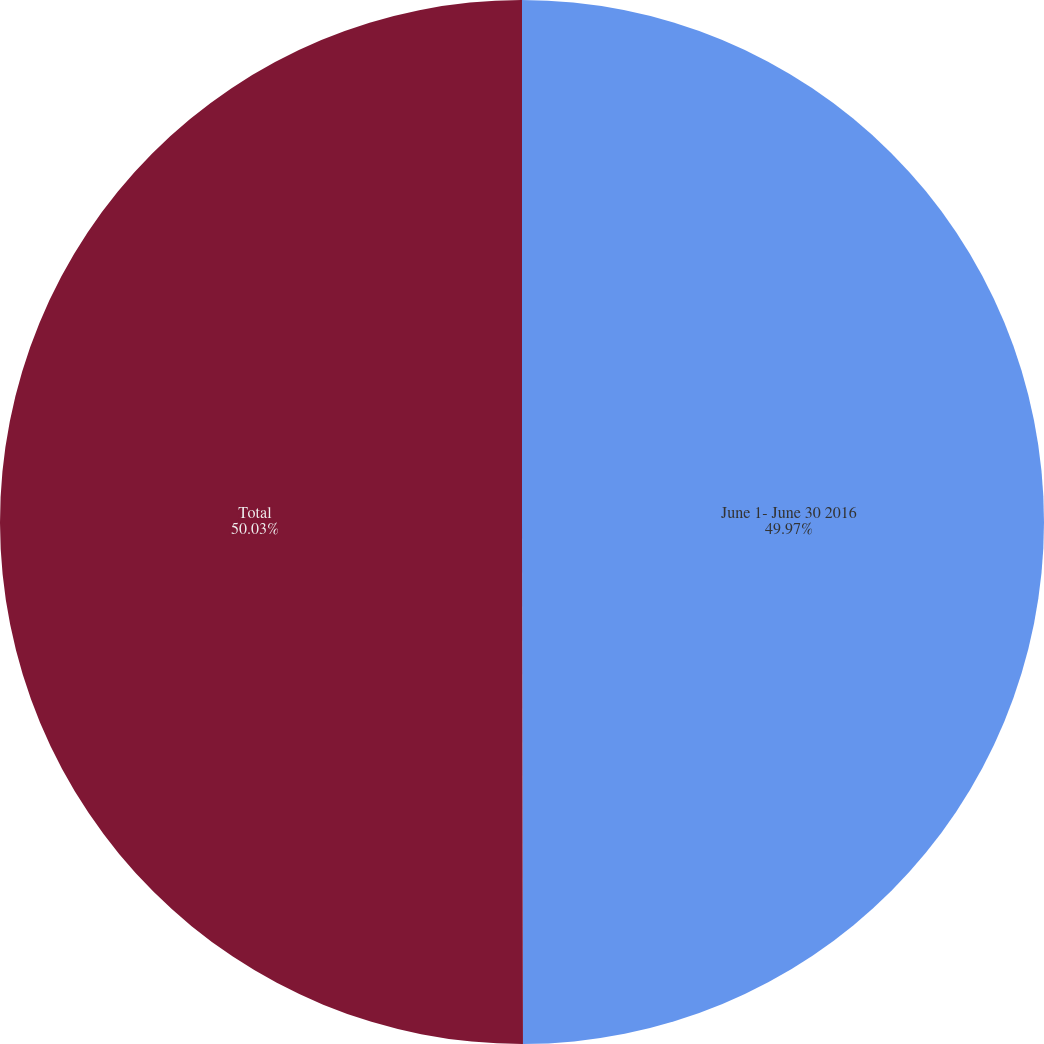Convert chart. <chart><loc_0><loc_0><loc_500><loc_500><pie_chart><fcel>June 1- June 30 2016<fcel>Total<nl><fcel>49.97%<fcel>50.03%<nl></chart> 